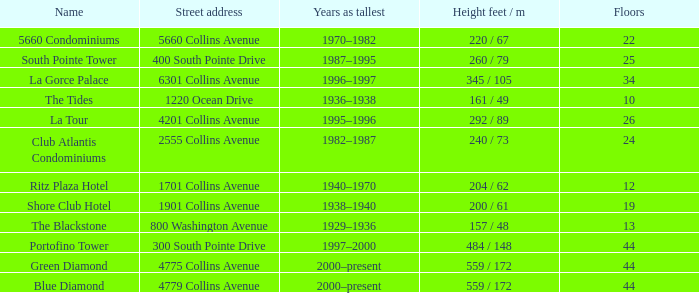How many years was the building with 24 floors the tallest? 1982–1987. 